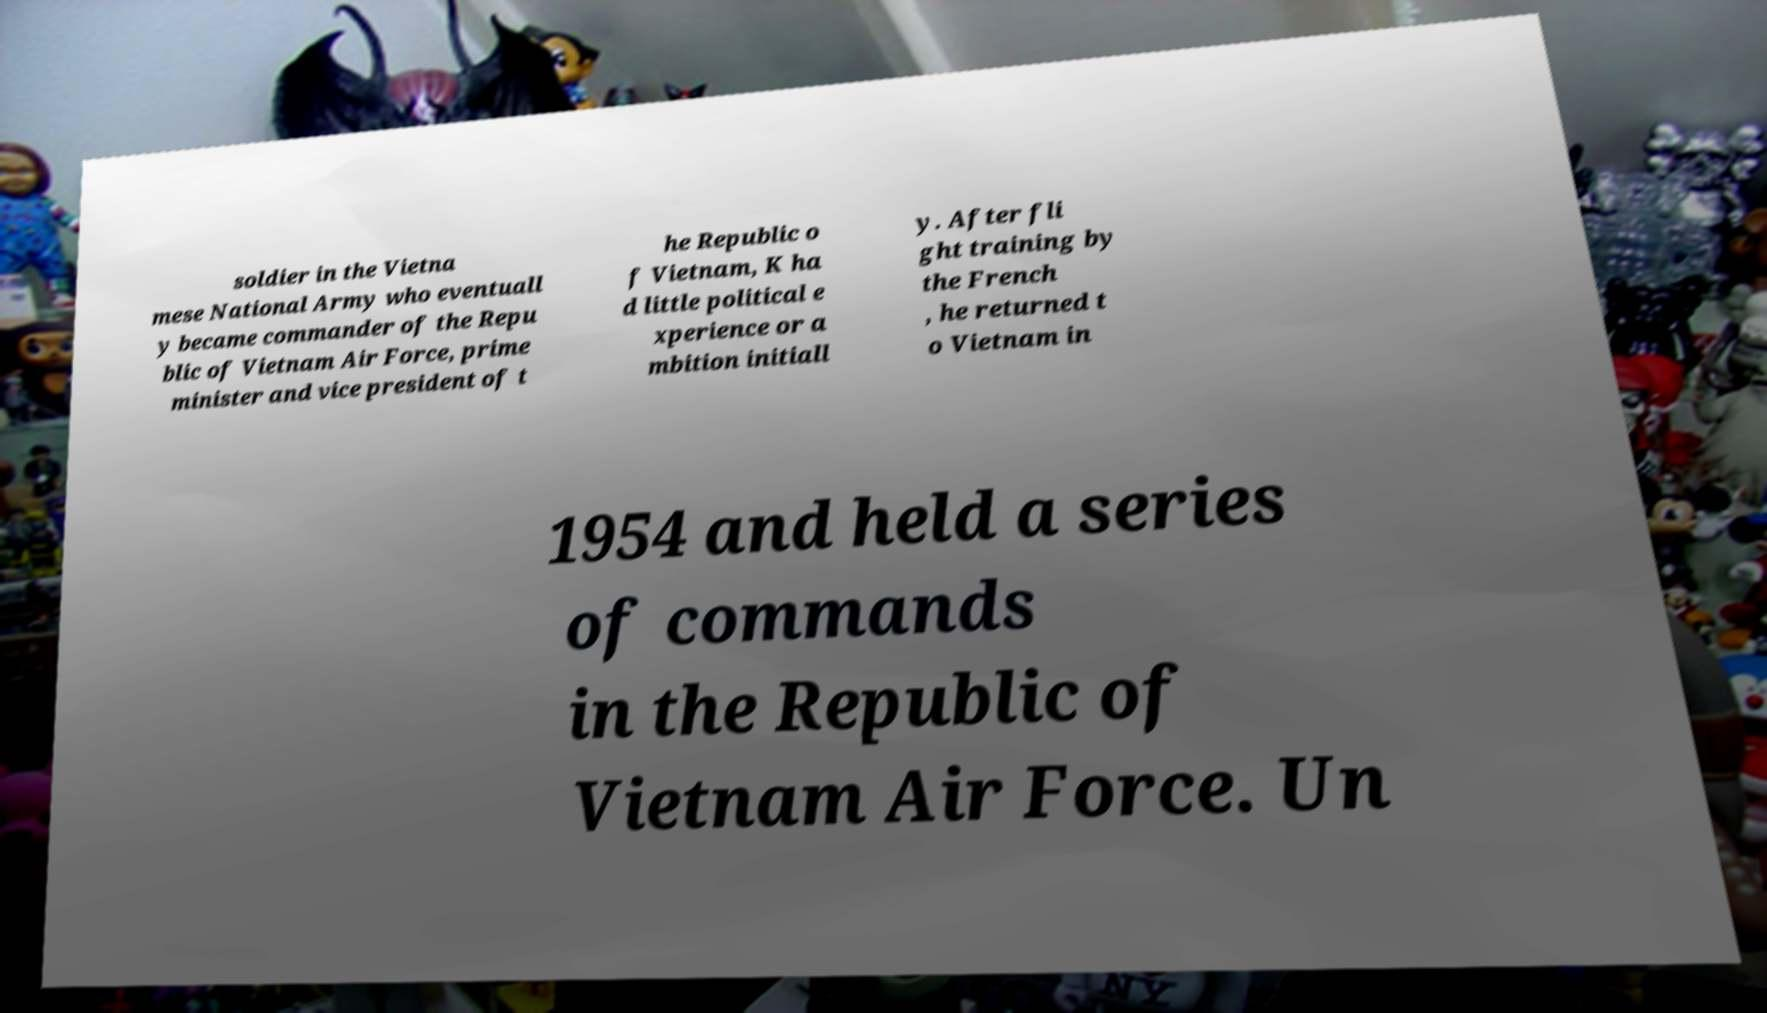Could you assist in decoding the text presented in this image and type it out clearly? soldier in the Vietna mese National Army who eventuall y became commander of the Repu blic of Vietnam Air Force, prime minister and vice president of t he Republic o f Vietnam, K ha d little political e xperience or a mbition initiall y. After fli ght training by the French , he returned t o Vietnam in 1954 and held a series of commands in the Republic of Vietnam Air Force. Un 